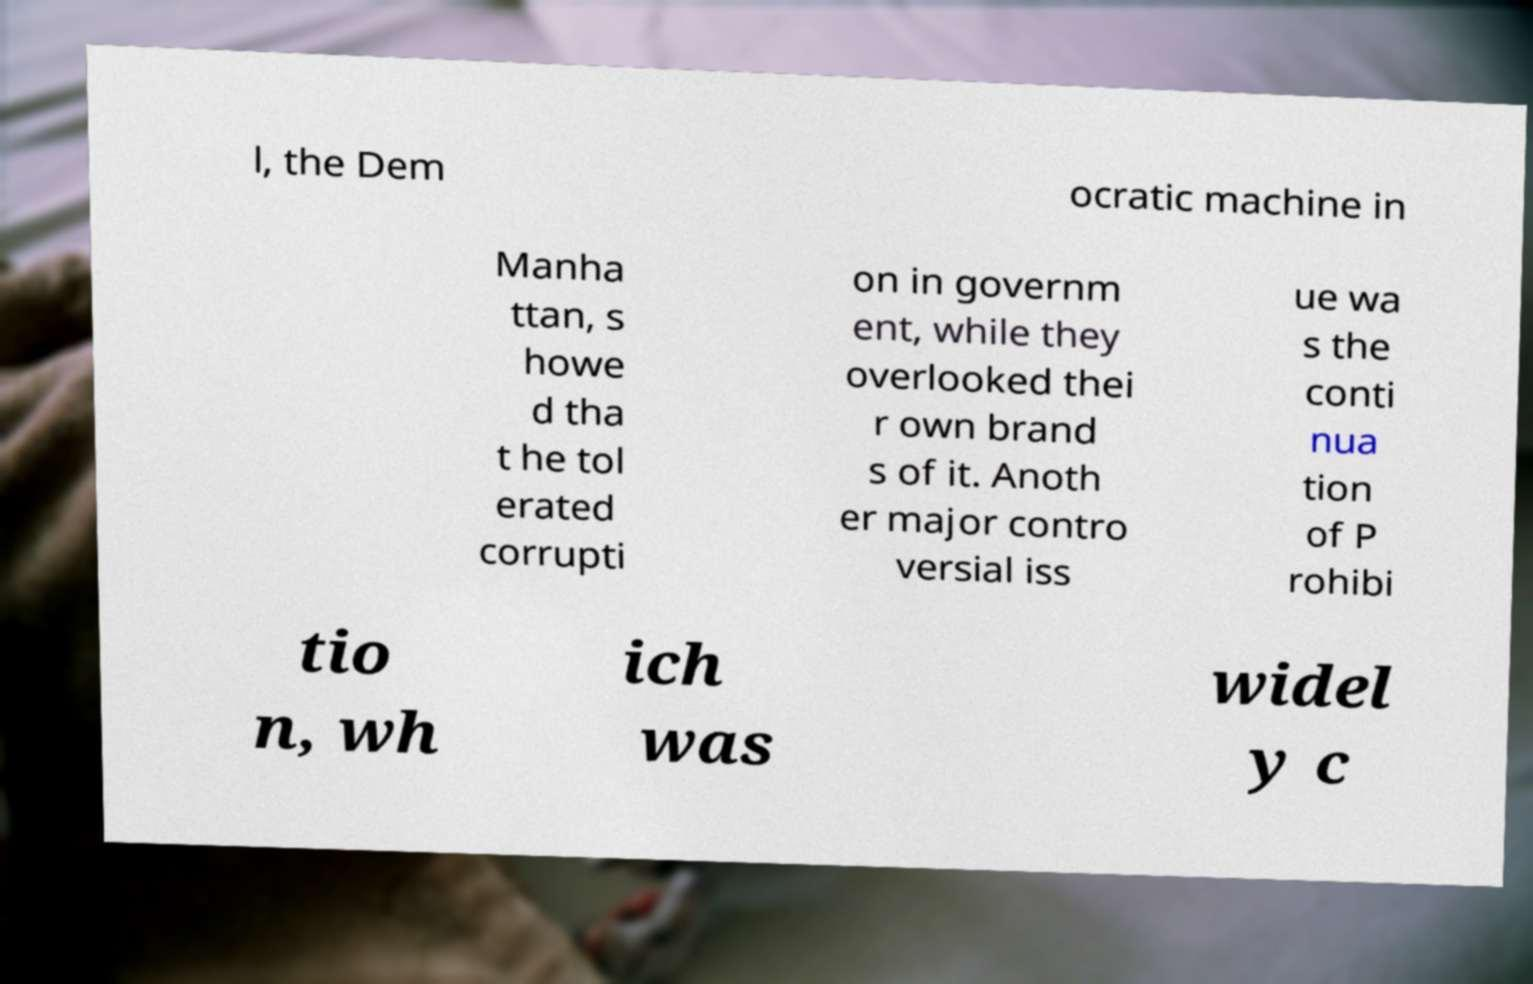Can you accurately transcribe the text from the provided image for me? l, the Dem ocratic machine in Manha ttan, s howe d tha t he tol erated corrupti on in governm ent, while they overlooked thei r own brand s of it. Anoth er major contro versial iss ue wa s the conti nua tion of P rohibi tio n, wh ich was widel y c 